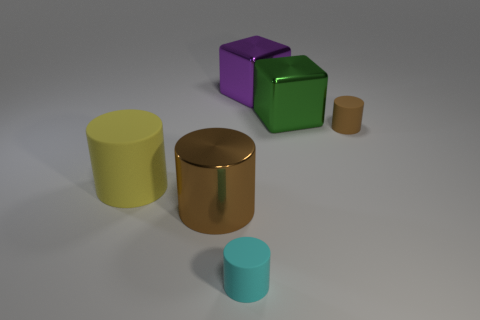Subtract all blue balls. How many brown cylinders are left? 2 Subtract 2 cylinders. How many cylinders are left? 2 Subtract all tiny cyan rubber cylinders. How many cylinders are left? 3 Add 4 small purple matte cylinders. How many objects exist? 10 Subtract all cyan cylinders. How many cylinders are left? 3 Subtract all cylinders. How many objects are left? 2 Subtract all tiny brown matte things. Subtract all blue metal blocks. How many objects are left? 5 Add 2 large cylinders. How many large cylinders are left? 4 Add 6 matte cylinders. How many matte cylinders exist? 9 Subtract 0 red cubes. How many objects are left? 6 